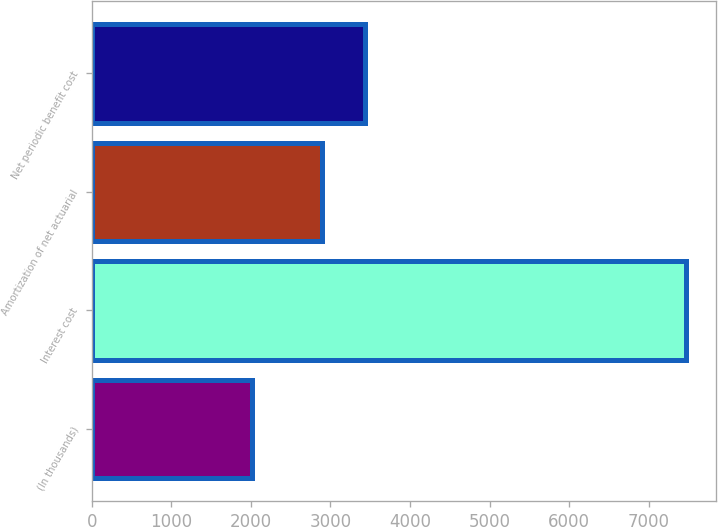Convert chart. <chart><loc_0><loc_0><loc_500><loc_500><bar_chart><fcel>(In thousands)<fcel>Interest cost<fcel>Amortization of net actuarial<fcel>Net periodic benefit cost<nl><fcel>2014<fcel>7468<fcel>2895<fcel>3440.4<nl></chart> 